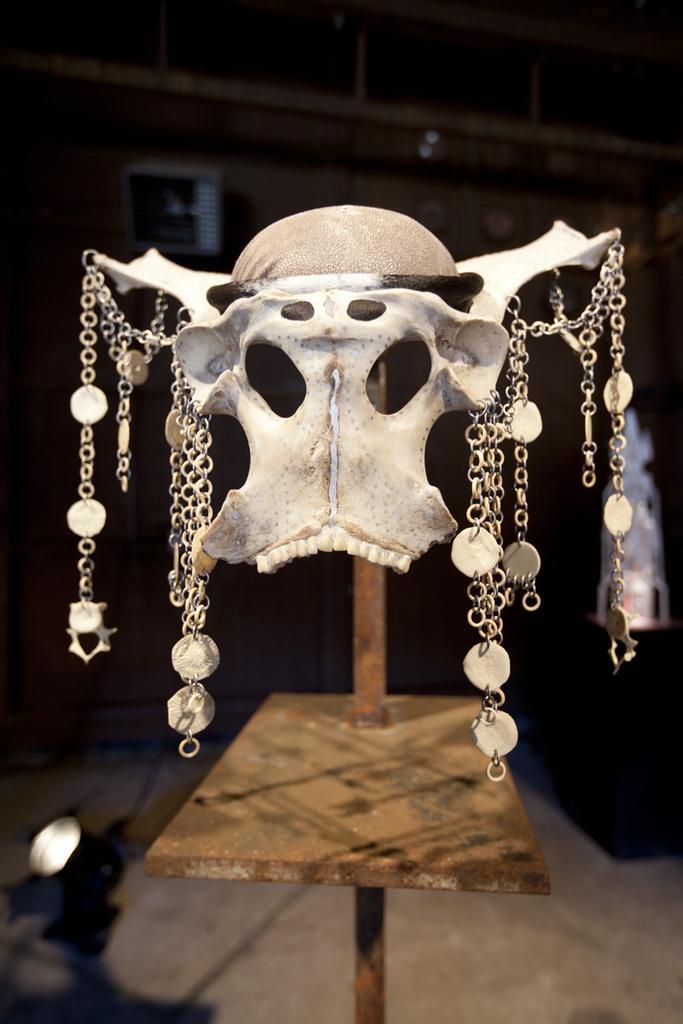Please provide a concise description of this image. In this image, in the middle, we can see a table. On the table, we can see a skeleton with few chains. In the background, we can see black color. 